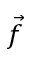Convert formula to latex. <formula><loc_0><loc_0><loc_500><loc_500>\vec { f }</formula> 